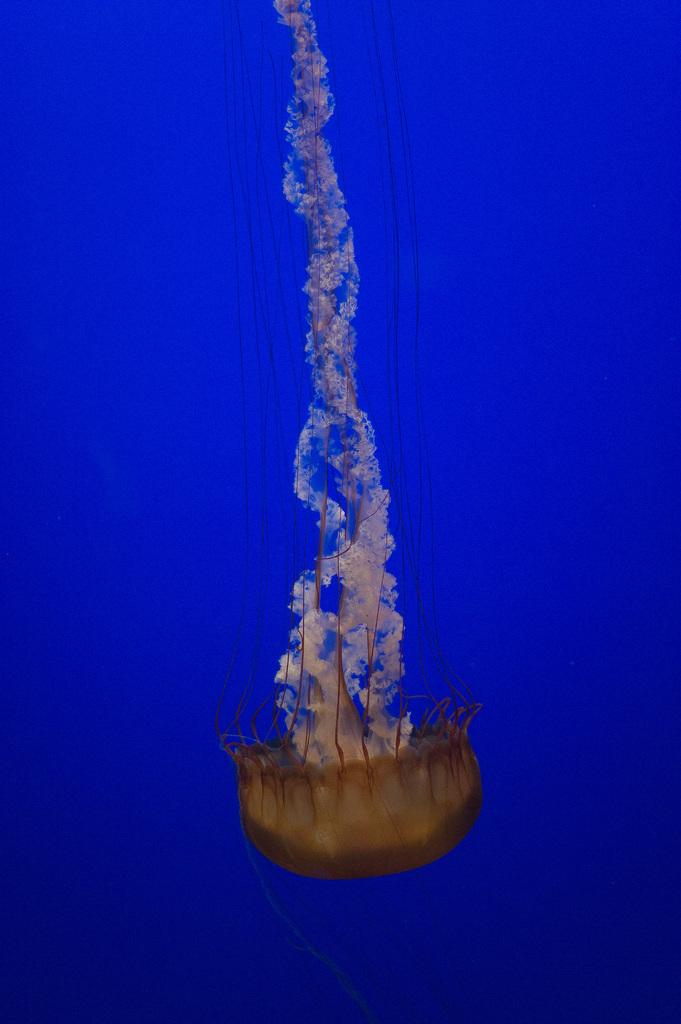What type of animal is in the image? There is a jellyfish in the image. Where is the jellyfish located? The jellyfish is in the water. What type of stem can be seen growing from the jellyfish in the image? There is no stem present in the image, as the subject is a jellyfish, which does not have a stem. 